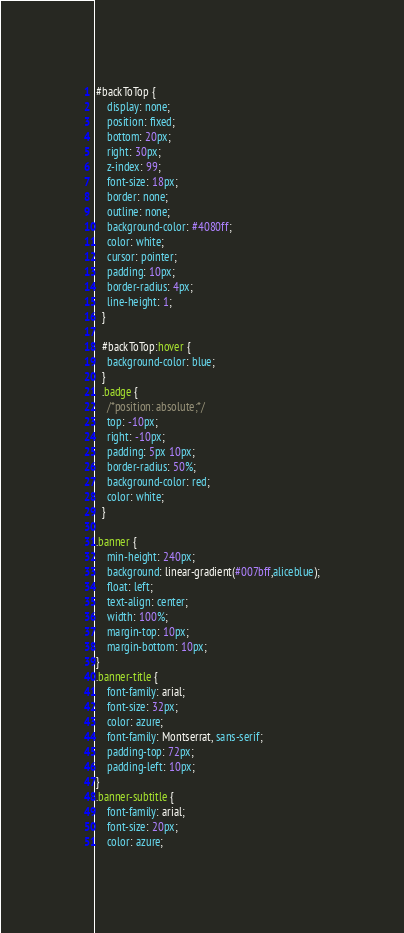Convert code to text. <code><loc_0><loc_0><loc_500><loc_500><_CSS_>#backToTop {
    display: none;
    position: fixed;
    bottom: 20px;
    right: 30px;
    z-index: 99;
    font-size: 18px;
    border: none;
    outline: none;
    background-color: #4080ff;
    color: white;
    cursor: pointer;
    padding: 10px;
    border-radius: 4px;
    line-height: 1;
  }
  
  #backToTop:hover {
    background-color: blue;
  }
  .badge {
    /*position: absolute;*/
    top: -10px;
    right: -10px;
    padding: 5px 10px;
    border-radius: 50%;
    background-color: red;
    color: white;
  }
  
.banner {
    min-height: 240px;
    background: linear-gradient(#007bff,aliceblue);
    float: left;
    text-align: center;
    width: 100%;
    margin-top: 10px;
    margin-bottom: 10px;
}
.banner-title {
    font-family: arial;
    font-size: 32px;
    color: azure;
    font-family: Montserrat, sans-serif;
    padding-top: 72px;
    padding-left: 10px;
}
.banner-subtitle {
    font-family: arial;
    font-size: 20px;
    color: azure;</code> 